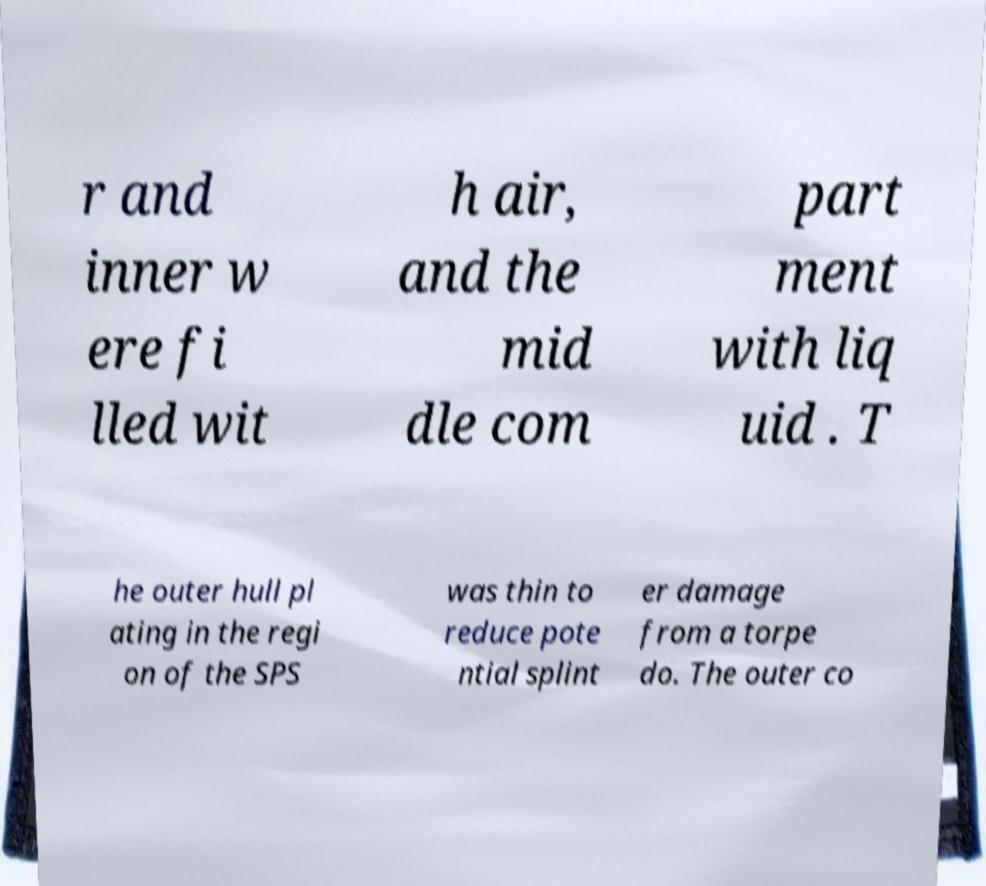For documentation purposes, I need the text within this image transcribed. Could you provide that? r and inner w ere fi lled wit h air, and the mid dle com part ment with liq uid . T he outer hull pl ating in the regi on of the SPS was thin to reduce pote ntial splint er damage from a torpe do. The outer co 